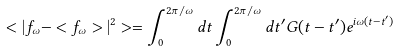<formula> <loc_0><loc_0><loc_500><loc_500>< | f _ { \omega } - < f _ { \omega } > | ^ { 2 } > = \int _ { 0 } ^ { 2 \pi / \omega } d t \int _ { 0 } ^ { 2 \pi / \omega } d t ^ { \prime } G ( t - t ^ { \prime } ) e ^ { i \omega ( t - t ^ { \prime } ) }</formula> 